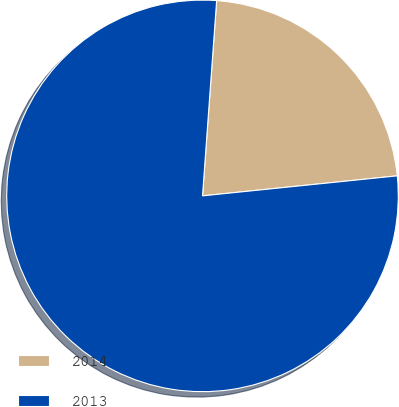Convert chart. <chart><loc_0><loc_0><loc_500><loc_500><pie_chart><fcel>2014<fcel>2013<nl><fcel>22.22%<fcel>77.78%<nl></chart> 